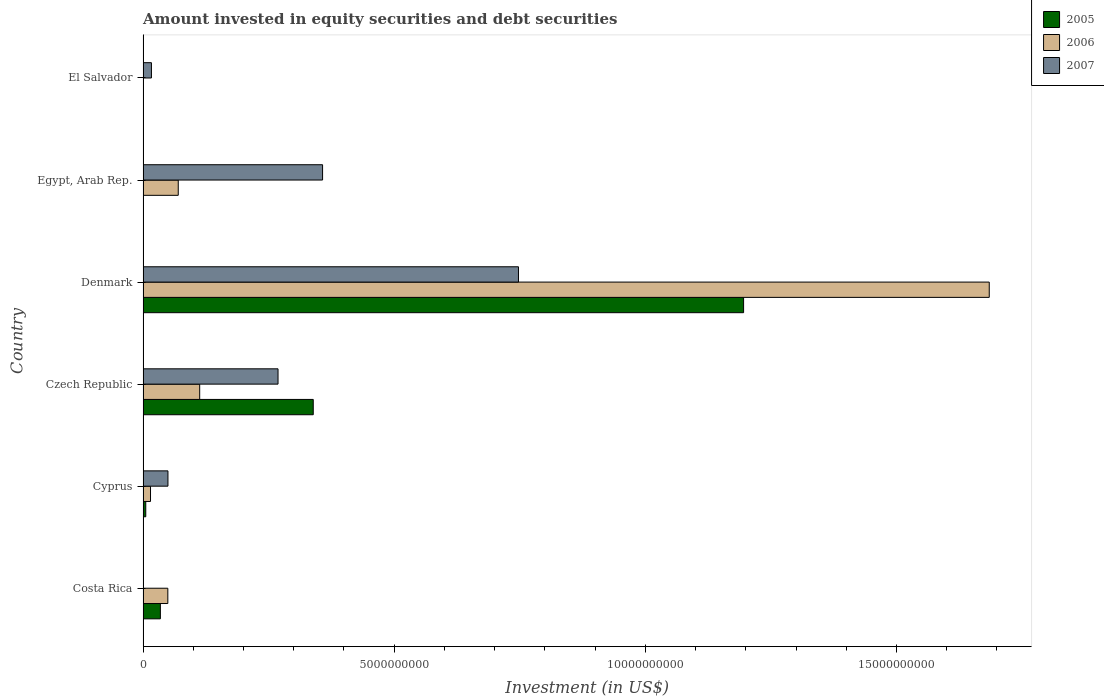How many different coloured bars are there?
Ensure brevity in your answer.  3. Are the number of bars on each tick of the Y-axis equal?
Give a very brief answer. No. What is the label of the 5th group of bars from the top?
Your answer should be very brief. Cyprus. What is the amount invested in equity securities and debt securities in 2005 in Denmark?
Make the answer very short. 1.20e+1. Across all countries, what is the maximum amount invested in equity securities and debt securities in 2006?
Your response must be concise. 1.68e+1. Across all countries, what is the minimum amount invested in equity securities and debt securities in 2007?
Provide a short and direct response. 3.93e+05. What is the total amount invested in equity securities and debt securities in 2007 in the graph?
Ensure brevity in your answer.  1.44e+1. What is the difference between the amount invested in equity securities and debt securities in 2006 in Costa Rica and that in Czech Republic?
Give a very brief answer. -6.34e+08. What is the difference between the amount invested in equity securities and debt securities in 2005 in El Salvador and the amount invested in equity securities and debt securities in 2007 in Denmark?
Ensure brevity in your answer.  -7.47e+09. What is the average amount invested in equity securities and debt securities in 2006 per country?
Offer a terse response. 3.22e+09. What is the difference between the amount invested in equity securities and debt securities in 2006 and amount invested in equity securities and debt securities in 2005 in Cyprus?
Provide a short and direct response. 9.46e+07. In how many countries, is the amount invested in equity securities and debt securities in 2005 greater than 15000000000 US$?
Give a very brief answer. 0. What is the ratio of the amount invested in equity securities and debt securities in 2007 in Cyprus to that in Denmark?
Offer a terse response. 0.07. Is the amount invested in equity securities and debt securities in 2007 in Egypt, Arab Rep. less than that in El Salvador?
Your answer should be very brief. No. What is the difference between the highest and the second highest amount invested in equity securities and debt securities in 2007?
Provide a succinct answer. 3.90e+09. What is the difference between the highest and the lowest amount invested in equity securities and debt securities in 2007?
Keep it short and to the point. 7.47e+09. Is the sum of the amount invested in equity securities and debt securities in 2005 in Czech Republic and Denmark greater than the maximum amount invested in equity securities and debt securities in 2006 across all countries?
Provide a short and direct response. No. Is it the case that in every country, the sum of the amount invested in equity securities and debt securities in 2007 and amount invested in equity securities and debt securities in 2005 is greater than the amount invested in equity securities and debt securities in 2006?
Provide a succinct answer. No. How many bars are there?
Ensure brevity in your answer.  15. How many countries are there in the graph?
Your answer should be compact. 6. What is the difference between two consecutive major ticks on the X-axis?
Give a very brief answer. 5.00e+09. Are the values on the major ticks of X-axis written in scientific E-notation?
Your answer should be very brief. No. Where does the legend appear in the graph?
Your response must be concise. Top right. What is the title of the graph?
Provide a succinct answer. Amount invested in equity securities and debt securities. What is the label or title of the X-axis?
Your response must be concise. Investment (in US$). What is the Investment (in US$) of 2005 in Costa Rica?
Your answer should be compact. 3.45e+08. What is the Investment (in US$) in 2006 in Costa Rica?
Ensure brevity in your answer.  4.93e+08. What is the Investment (in US$) of 2007 in Costa Rica?
Your answer should be compact. 3.93e+05. What is the Investment (in US$) of 2005 in Cyprus?
Offer a very short reply. 5.37e+07. What is the Investment (in US$) in 2006 in Cyprus?
Your answer should be compact. 1.48e+08. What is the Investment (in US$) of 2007 in Cyprus?
Provide a short and direct response. 4.96e+08. What is the Investment (in US$) in 2005 in Czech Republic?
Provide a succinct answer. 3.39e+09. What is the Investment (in US$) in 2006 in Czech Republic?
Ensure brevity in your answer.  1.13e+09. What is the Investment (in US$) in 2007 in Czech Republic?
Ensure brevity in your answer.  2.69e+09. What is the Investment (in US$) in 2005 in Denmark?
Give a very brief answer. 1.20e+1. What is the Investment (in US$) in 2006 in Denmark?
Ensure brevity in your answer.  1.68e+1. What is the Investment (in US$) in 2007 in Denmark?
Offer a very short reply. 7.47e+09. What is the Investment (in US$) of 2006 in Egypt, Arab Rep.?
Keep it short and to the point. 7.00e+08. What is the Investment (in US$) of 2007 in Egypt, Arab Rep.?
Your answer should be compact. 3.57e+09. What is the Investment (in US$) of 2005 in El Salvador?
Offer a terse response. 0. What is the Investment (in US$) in 2007 in El Salvador?
Your answer should be very brief. 1.67e+08. Across all countries, what is the maximum Investment (in US$) in 2005?
Offer a terse response. 1.20e+1. Across all countries, what is the maximum Investment (in US$) in 2006?
Your answer should be compact. 1.68e+1. Across all countries, what is the maximum Investment (in US$) of 2007?
Your response must be concise. 7.47e+09. Across all countries, what is the minimum Investment (in US$) in 2007?
Provide a succinct answer. 3.93e+05. What is the total Investment (in US$) of 2005 in the graph?
Your answer should be very brief. 1.57e+1. What is the total Investment (in US$) in 2006 in the graph?
Your answer should be compact. 1.93e+1. What is the total Investment (in US$) of 2007 in the graph?
Your answer should be very brief. 1.44e+1. What is the difference between the Investment (in US$) in 2005 in Costa Rica and that in Cyprus?
Offer a very short reply. 2.91e+08. What is the difference between the Investment (in US$) in 2006 in Costa Rica and that in Cyprus?
Give a very brief answer. 3.45e+08. What is the difference between the Investment (in US$) in 2007 in Costa Rica and that in Cyprus?
Keep it short and to the point. -4.95e+08. What is the difference between the Investment (in US$) in 2005 in Costa Rica and that in Czech Republic?
Provide a short and direct response. -3.04e+09. What is the difference between the Investment (in US$) in 2006 in Costa Rica and that in Czech Republic?
Offer a very short reply. -6.34e+08. What is the difference between the Investment (in US$) of 2007 in Costa Rica and that in Czech Republic?
Keep it short and to the point. -2.69e+09. What is the difference between the Investment (in US$) of 2005 in Costa Rica and that in Denmark?
Provide a short and direct response. -1.16e+1. What is the difference between the Investment (in US$) of 2006 in Costa Rica and that in Denmark?
Provide a succinct answer. -1.64e+1. What is the difference between the Investment (in US$) of 2007 in Costa Rica and that in Denmark?
Ensure brevity in your answer.  -7.47e+09. What is the difference between the Investment (in US$) of 2006 in Costa Rica and that in Egypt, Arab Rep.?
Provide a short and direct response. -2.07e+08. What is the difference between the Investment (in US$) of 2007 in Costa Rica and that in Egypt, Arab Rep.?
Provide a succinct answer. -3.57e+09. What is the difference between the Investment (in US$) of 2007 in Costa Rica and that in El Salvador?
Offer a very short reply. -1.66e+08. What is the difference between the Investment (in US$) in 2005 in Cyprus and that in Czech Republic?
Make the answer very short. -3.33e+09. What is the difference between the Investment (in US$) of 2006 in Cyprus and that in Czech Republic?
Keep it short and to the point. -9.79e+08. What is the difference between the Investment (in US$) of 2007 in Cyprus and that in Czech Republic?
Offer a terse response. -2.19e+09. What is the difference between the Investment (in US$) of 2005 in Cyprus and that in Denmark?
Your answer should be very brief. -1.19e+1. What is the difference between the Investment (in US$) of 2006 in Cyprus and that in Denmark?
Make the answer very short. -1.67e+1. What is the difference between the Investment (in US$) of 2007 in Cyprus and that in Denmark?
Offer a very short reply. -6.98e+09. What is the difference between the Investment (in US$) of 2006 in Cyprus and that in Egypt, Arab Rep.?
Provide a succinct answer. -5.52e+08. What is the difference between the Investment (in US$) of 2007 in Cyprus and that in Egypt, Arab Rep.?
Make the answer very short. -3.08e+09. What is the difference between the Investment (in US$) in 2007 in Cyprus and that in El Salvador?
Provide a short and direct response. 3.29e+08. What is the difference between the Investment (in US$) in 2005 in Czech Republic and that in Denmark?
Provide a succinct answer. -8.57e+09. What is the difference between the Investment (in US$) in 2006 in Czech Republic and that in Denmark?
Offer a very short reply. -1.57e+1. What is the difference between the Investment (in US$) in 2007 in Czech Republic and that in Denmark?
Your answer should be compact. -4.79e+09. What is the difference between the Investment (in US$) of 2006 in Czech Republic and that in Egypt, Arab Rep.?
Your answer should be very brief. 4.27e+08. What is the difference between the Investment (in US$) in 2007 in Czech Republic and that in Egypt, Arab Rep.?
Your response must be concise. -8.87e+08. What is the difference between the Investment (in US$) of 2007 in Czech Republic and that in El Salvador?
Make the answer very short. 2.52e+09. What is the difference between the Investment (in US$) in 2006 in Denmark and that in Egypt, Arab Rep.?
Ensure brevity in your answer.  1.61e+1. What is the difference between the Investment (in US$) in 2007 in Denmark and that in Egypt, Arab Rep.?
Provide a short and direct response. 3.90e+09. What is the difference between the Investment (in US$) in 2007 in Denmark and that in El Salvador?
Provide a succinct answer. 7.31e+09. What is the difference between the Investment (in US$) of 2007 in Egypt, Arab Rep. and that in El Salvador?
Ensure brevity in your answer.  3.41e+09. What is the difference between the Investment (in US$) of 2005 in Costa Rica and the Investment (in US$) of 2006 in Cyprus?
Your answer should be very brief. 1.96e+08. What is the difference between the Investment (in US$) of 2005 in Costa Rica and the Investment (in US$) of 2007 in Cyprus?
Keep it short and to the point. -1.51e+08. What is the difference between the Investment (in US$) of 2006 in Costa Rica and the Investment (in US$) of 2007 in Cyprus?
Provide a short and direct response. -2.46e+06. What is the difference between the Investment (in US$) in 2005 in Costa Rica and the Investment (in US$) in 2006 in Czech Republic?
Offer a terse response. -7.83e+08. What is the difference between the Investment (in US$) in 2005 in Costa Rica and the Investment (in US$) in 2007 in Czech Republic?
Your answer should be very brief. -2.34e+09. What is the difference between the Investment (in US$) in 2006 in Costa Rica and the Investment (in US$) in 2007 in Czech Republic?
Your response must be concise. -2.19e+09. What is the difference between the Investment (in US$) of 2005 in Costa Rica and the Investment (in US$) of 2006 in Denmark?
Offer a terse response. -1.65e+1. What is the difference between the Investment (in US$) of 2005 in Costa Rica and the Investment (in US$) of 2007 in Denmark?
Provide a succinct answer. -7.13e+09. What is the difference between the Investment (in US$) in 2006 in Costa Rica and the Investment (in US$) in 2007 in Denmark?
Offer a very short reply. -6.98e+09. What is the difference between the Investment (in US$) of 2005 in Costa Rica and the Investment (in US$) of 2006 in Egypt, Arab Rep.?
Your answer should be very brief. -3.56e+08. What is the difference between the Investment (in US$) in 2005 in Costa Rica and the Investment (in US$) in 2007 in Egypt, Arab Rep.?
Give a very brief answer. -3.23e+09. What is the difference between the Investment (in US$) in 2006 in Costa Rica and the Investment (in US$) in 2007 in Egypt, Arab Rep.?
Your answer should be compact. -3.08e+09. What is the difference between the Investment (in US$) of 2005 in Costa Rica and the Investment (in US$) of 2007 in El Salvador?
Your answer should be very brief. 1.78e+08. What is the difference between the Investment (in US$) in 2006 in Costa Rica and the Investment (in US$) in 2007 in El Salvador?
Your answer should be very brief. 3.26e+08. What is the difference between the Investment (in US$) in 2005 in Cyprus and the Investment (in US$) in 2006 in Czech Republic?
Your answer should be compact. -1.07e+09. What is the difference between the Investment (in US$) of 2005 in Cyprus and the Investment (in US$) of 2007 in Czech Republic?
Offer a very short reply. -2.63e+09. What is the difference between the Investment (in US$) in 2006 in Cyprus and the Investment (in US$) in 2007 in Czech Republic?
Keep it short and to the point. -2.54e+09. What is the difference between the Investment (in US$) of 2005 in Cyprus and the Investment (in US$) of 2006 in Denmark?
Your answer should be very brief. -1.68e+1. What is the difference between the Investment (in US$) in 2005 in Cyprus and the Investment (in US$) in 2007 in Denmark?
Provide a short and direct response. -7.42e+09. What is the difference between the Investment (in US$) of 2006 in Cyprus and the Investment (in US$) of 2007 in Denmark?
Offer a very short reply. -7.33e+09. What is the difference between the Investment (in US$) of 2005 in Cyprus and the Investment (in US$) of 2006 in Egypt, Arab Rep.?
Make the answer very short. -6.47e+08. What is the difference between the Investment (in US$) in 2005 in Cyprus and the Investment (in US$) in 2007 in Egypt, Arab Rep.?
Your response must be concise. -3.52e+09. What is the difference between the Investment (in US$) in 2006 in Cyprus and the Investment (in US$) in 2007 in Egypt, Arab Rep.?
Your answer should be very brief. -3.43e+09. What is the difference between the Investment (in US$) in 2005 in Cyprus and the Investment (in US$) in 2007 in El Salvador?
Make the answer very short. -1.13e+08. What is the difference between the Investment (in US$) in 2006 in Cyprus and the Investment (in US$) in 2007 in El Salvador?
Your answer should be compact. -1.85e+07. What is the difference between the Investment (in US$) of 2005 in Czech Republic and the Investment (in US$) of 2006 in Denmark?
Provide a succinct answer. -1.35e+1. What is the difference between the Investment (in US$) of 2005 in Czech Republic and the Investment (in US$) of 2007 in Denmark?
Ensure brevity in your answer.  -4.09e+09. What is the difference between the Investment (in US$) of 2006 in Czech Republic and the Investment (in US$) of 2007 in Denmark?
Keep it short and to the point. -6.35e+09. What is the difference between the Investment (in US$) of 2005 in Czech Republic and the Investment (in US$) of 2006 in Egypt, Arab Rep.?
Give a very brief answer. 2.69e+09. What is the difference between the Investment (in US$) of 2005 in Czech Republic and the Investment (in US$) of 2007 in Egypt, Arab Rep.?
Provide a short and direct response. -1.86e+08. What is the difference between the Investment (in US$) of 2006 in Czech Republic and the Investment (in US$) of 2007 in Egypt, Arab Rep.?
Ensure brevity in your answer.  -2.45e+09. What is the difference between the Investment (in US$) of 2005 in Czech Republic and the Investment (in US$) of 2007 in El Salvador?
Keep it short and to the point. 3.22e+09. What is the difference between the Investment (in US$) of 2006 in Czech Republic and the Investment (in US$) of 2007 in El Salvador?
Provide a short and direct response. 9.61e+08. What is the difference between the Investment (in US$) in 2005 in Denmark and the Investment (in US$) in 2006 in Egypt, Arab Rep.?
Make the answer very short. 1.13e+1. What is the difference between the Investment (in US$) of 2005 in Denmark and the Investment (in US$) of 2007 in Egypt, Arab Rep.?
Your answer should be very brief. 8.38e+09. What is the difference between the Investment (in US$) of 2006 in Denmark and the Investment (in US$) of 2007 in Egypt, Arab Rep.?
Your response must be concise. 1.33e+1. What is the difference between the Investment (in US$) in 2005 in Denmark and the Investment (in US$) in 2007 in El Salvador?
Offer a terse response. 1.18e+1. What is the difference between the Investment (in US$) in 2006 in Denmark and the Investment (in US$) in 2007 in El Salvador?
Ensure brevity in your answer.  1.67e+1. What is the difference between the Investment (in US$) in 2006 in Egypt, Arab Rep. and the Investment (in US$) in 2007 in El Salvador?
Your answer should be very brief. 5.34e+08. What is the average Investment (in US$) in 2005 per country?
Provide a short and direct response. 2.62e+09. What is the average Investment (in US$) of 2006 per country?
Make the answer very short. 3.22e+09. What is the average Investment (in US$) in 2007 per country?
Provide a short and direct response. 2.40e+09. What is the difference between the Investment (in US$) in 2005 and Investment (in US$) in 2006 in Costa Rica?
Keep it short and to the point. -1.49e+08. What is the difference between the Investment (in US$) in 2005 and Investment (in US$) in 2007 in Costa Rica?
Your answer should be compact. 3.44e+08. What is the difference between the Investment (in US$) of 2006 and Investment (in US$) of 2007 in Costa Rica?
Provide a short and direct response. 4.93e+08. What is the difference between the Investment (in US$) in 2005 and Investment (in US$) in 2006 in Cyprus?
Keep it short and to the point. -9.46e+07. What is the difference between the Investment (in US$) in 2005 and Investment (in US$) in 2007 in Cyprus?
Keep it short and to the point. -4.42e+08. What is the difference between the Investment (in US$) of 2006 and Investment (in US$) of 2007 in Cyprus?
Provide a succinct answer. -3.47e+08. What is the difference between the Investment (in US$) of 2005 and Investment (in US$) of 2006 in Czech Republic?
Offer a terse response. 2.26e+09. What is the difference between the Investment (in US$) in 2005 and Investment (in US$) in 2007 in Czech Republic?
Offer a very short reply. 7.01e+08. What is the difference between the Investment (in US$) of 2006 and Investment (in US$) of 2007 in Czech Republic?
Your answer should be very brief. -1.56e+09. What is the difference between the Investment (in US$) of 2005 and Investment (in US$) of 2006 in Denmark?
Keep it short and to the point. -4.89e+09. What is the difference between the Investment (in US$) in 2005 and Investment (in US$) in 2007 in Denmark?
Provide a succinct answer. 4.48e+09. What is the difference between the Investment (in US$) in 2006 and Investment (in US$) in 2007 in Denmark?
Your response must be concise. 9.37e+09. What is the difference between the Investment (in US$) of 2006 and Investment (in US$) of 2007 in Egypt, Arab Rep.?
Keep it short and to the point. -2.87e+09. What is the ratio of the Investment (in US$) of 2005 in Costa Rica to that in Cyprus?
Make the answer very short. 6.41. What is the ratio of the Investment (in US$) of 2006 in Costa Rica to that in Cyprus?
Keep it short and to the point. 3.32. What is the ratio of the Investment (in US$) in 2007 in Costa Rica to that in Cyprus?
Keep it short and to the point. 0. What is the ratio of the Investment (in US$) in 2005 in Costa Rica to that in Czech Republic?
Make the answer very short. 0.1. What is the ratio of the Investment (in US$) in 2006 in Costa Rica to that in Czech Republic?
Your answer should be very brief. 0.44. What is the ratio of the Investment (in US$) in 2007 in Costa Rica to that in Czech Republic?
Offer a terse response. 0. What is the ratio of the Investment (in US$) of 2005 in Costa Rica to that in Denmark?
Your response must be concise. 0.03. What is the ratio of the Investment (in US$) of 2006 in Costa Rica to that in Denmark?
Offer a terse response. 0.03. What is the ratio of the Investment (in US$) in 2007 in Costa Rica to that in Denmark?
Give a very brief answer. 0. What is the ratio of the Investment (in US$) in 2006 in Costa Rica to that in Egypt, Arab Rep.?
Offer a terse response. 0.7. What is the ratio of the Investment (in US$) in 2007 in Costa Rica to that in Egypt, Arab Rep.?
Offer a very short reply. 0. What is the ratio of the Investment (in US$) of 2007 in Costa Rica to that in El Salvador?
Provide a succinct answer. 0. What is the ratio of the Investment (in US$) in 2005 in Cyprus to that in Czech Republic?
Your response must be concise. 0.02. What is the ratio of the Investment (in US$) of 2006 in Cyprus to that in Czech Republic?
Provide a succinct answer. 0.13. What is the ratio of the Investment (in US$) of 2007 in Cyprus to that in Czech Republic?
Your response must be concise. 0.18. What is the ratio of the Investment (in US$) in 2005 in Cyprus to that in Denmark?
Provide a succinct answer. 0. What is the ratio of the Investment (in US$) in 2006 in Cyprus to that in Denmark?
Your response must be concise. 0.01. What is the ratio of the Investment (in US$) of 2007 in Cyprus to that in Denmark?
Give a very brief answer. 0.07. What is the ratio of the Investment (in US$) in 2006 in Cyprus to that in Egypt, Arab Rep.?
Offer a terse response. 0.21. What is the ratio of the Investment (in US$) of 2007 in Cyprus to that in Egypt, Arab Rep.?
Provide a succinct answer. 0.14. What is the ratio of the Investment (in US$) of 2007 in Cyprus to that in El Salvador?
Ensure brevity in your answer.  2.97. What is the ratio of the Investment (in US$) in 2005 in Czech Republic to that in Denmark?
Offer a terse response. 0.28. What is the ratio of the Investment (in US$) in 2006 in Czech Republic to that in Denmark?
Offer a terse response. 0.07. What is the ratio of the Investment (in US$) of 2007 in Czech Republic to that in Denmark?
Your answer should be very brief. 0.36. What is the ratio of the Investment (in US$) of 2006 in Czech Republic to that in Egypt, Arab Rep.?
Your response must be concise. 1.61. What is the ratio of the Investment (in US$) of 2007 in Czech Republic to that in Egypt, Arab Rep.?
Give a very brief answer. 0.75. What is the ratio of the Investment (in US$) in 2007 in Czech Republic to that in El Salvador?
Your answer should be very brief. 16.11. What is the ratio of the Investment (in US$) of 2006 in Denmark to that in Egypt, Arab Rep.?
Offer a terse response. 24.05. What is the ratio of the Investment (in US$) in 2007 in Denmark to that in Egypt, Arab Rep.?
Your response must be concise. 2.09. What is the ratio of the Investment (in US$) in 2007 in Denmark to that in El Salvador?
Keep it short and to the point. 44.81. What is the ratio of the Investment (in US$) of 2007 in Egypt, Arab Rep. to that in El Salvador?
Make the answer very short. 21.43. What is the difference between the highest and the second highest Investment (in US$) in 2005?
Your response must be concise. 8.57e+09. What is the difference between the highest and the second highest Investment (in US$) in 2006?
Give a very brief answer. 1.57e+1. What is the difference between the highest and the second highest Investment (in US$) of 2007?
Provide a succinct answer. 3.90e+09. What is the difference between the highest and the lowest Investment (in US$) in 2005?
Your answer should be compact. 1.20e+1. What is the difference between the highest and the lowest Investment (in US$) of 2006?
Keep it short and to the point. 1.68e+1. What is the difference between the highest and the lowest Investment (in US$) in 2007?
Your response must be concise. 7.47e+09. 